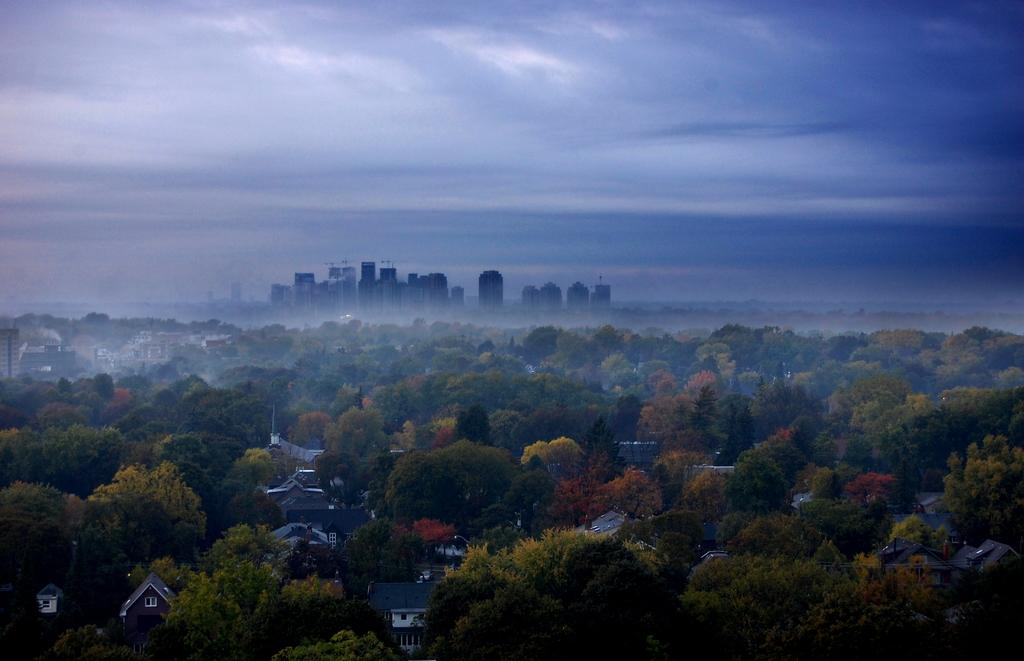What type of natural elements can be seen in the image? There are many trees in the image. What type of man-made structures are present in the image? There are buildings in the image. Can you describe the size of the buildings in the background? There are huge buildings in the background of the image. What is visible in the sky in the image? The sky is clear and visible in the image. What type of tax is being discussed in the image? There is no discussion of tax in the image; it features trees and buildings. How many cars are parked near the buildings in the image? There is no mention of cars in the image; it only shows trees and buildings. 